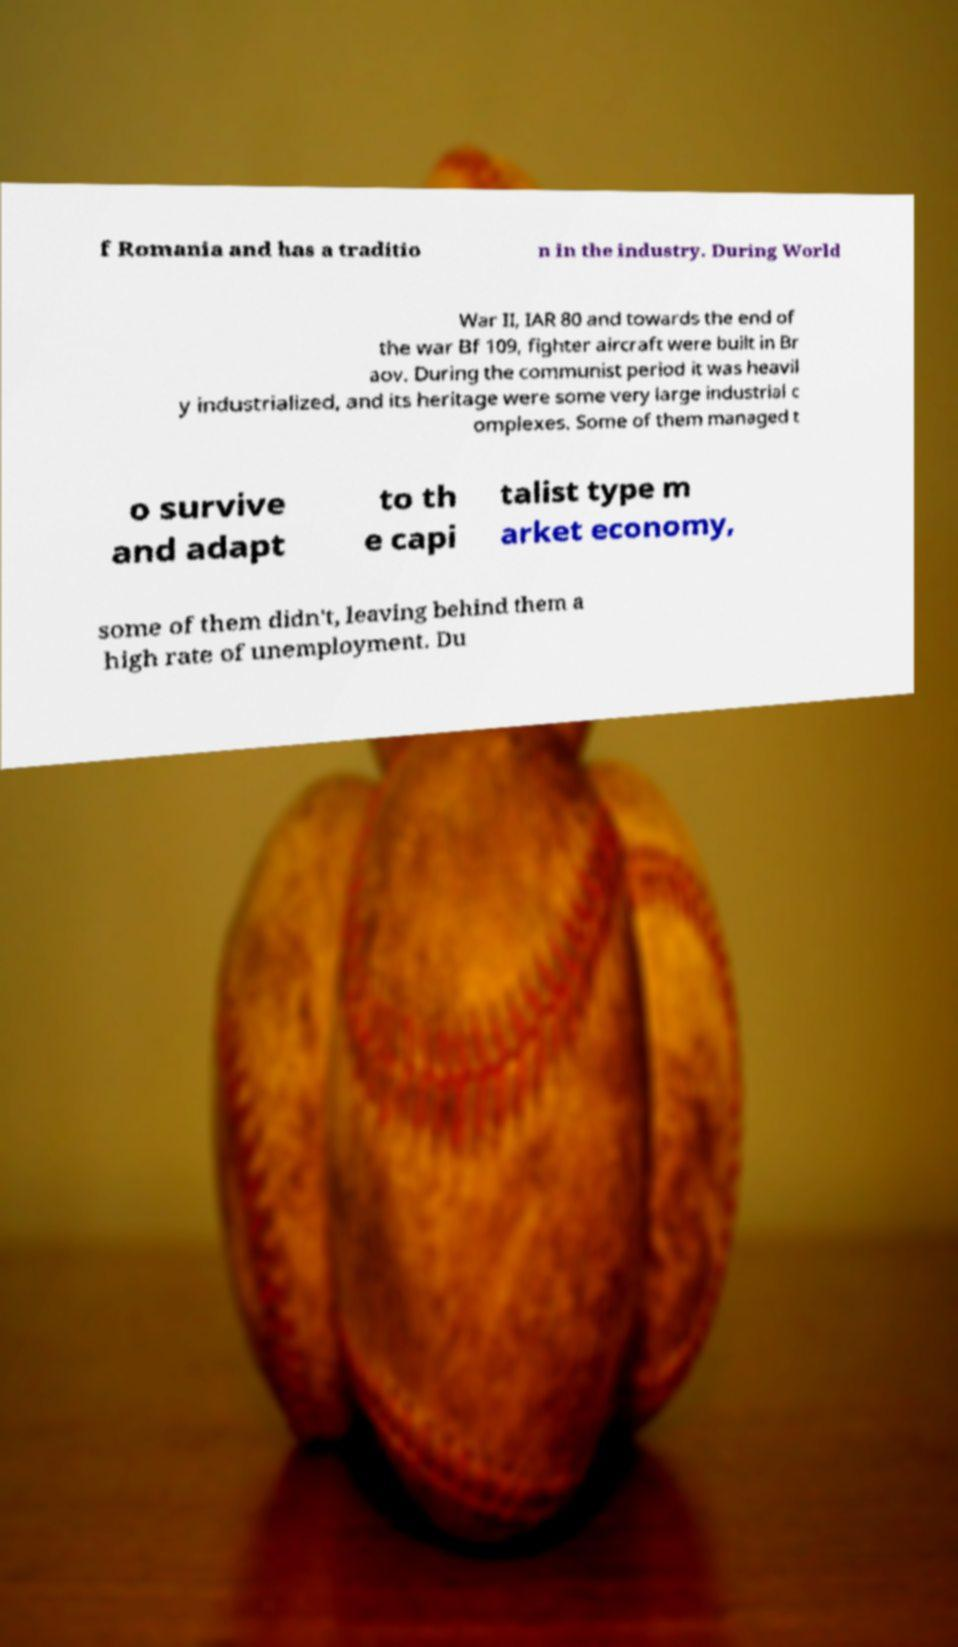Could you extract and type out the text from this image? f Romania and has a traditio n in the industry. During World War II, IAR 80 and towards the end of the war Bf 109, fighter aircraft were built in Br aov. During the communist period it was heavil y industrialized, and its heritage were some very large industrial c omplexes. Some of them managed t o survive and adapt to th e capi talist type m arket economy, some of them didn't, leaving behind them a high rate of unemployment. Du 